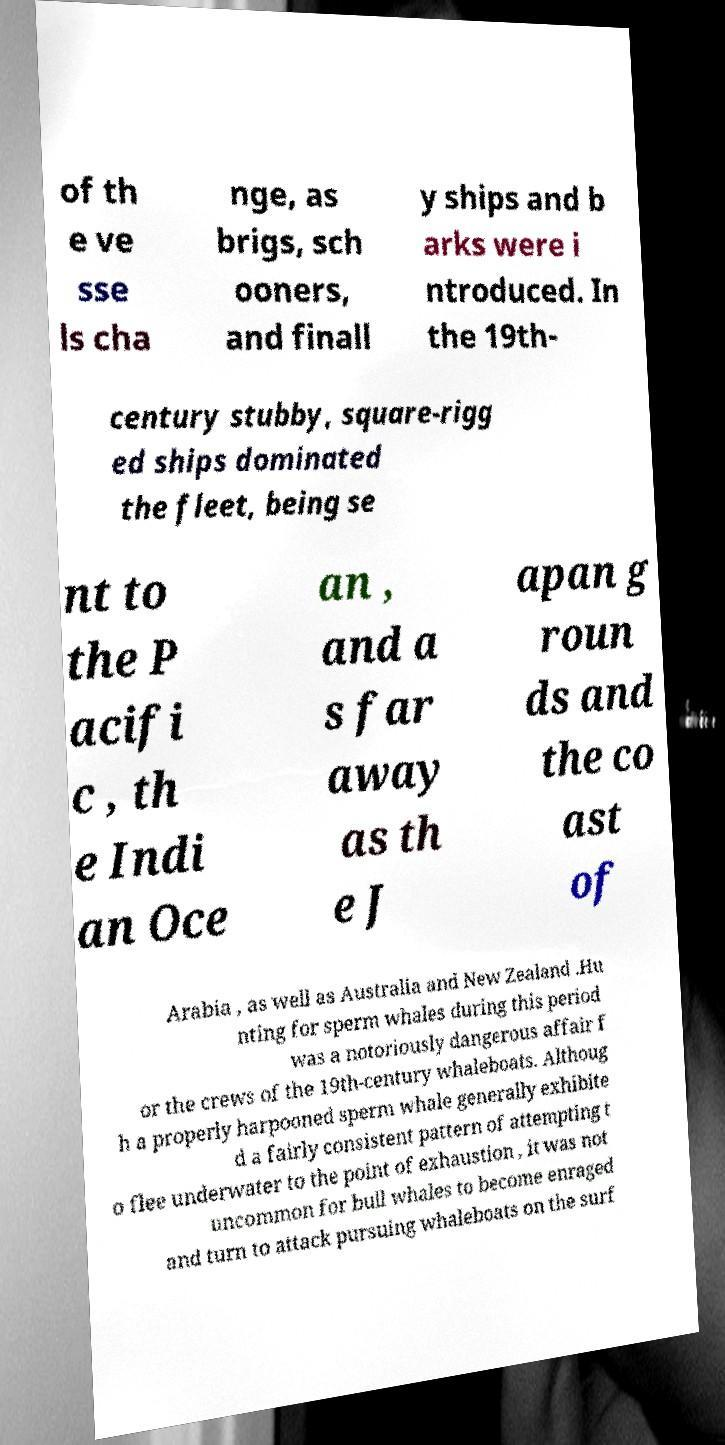For documentation purposes, I need the text within this image transcribed. Could you provide that? of th e ve sse ls cha nge, as brigs, sch ooners, and finall y ships and b arks were i ntroduced. In the 19th- century stubby, square-rigg ed ships dominated the fleet, being se nt to the P acifi c , th e Indi an Oce an , and a s far away as th e J apan g roun ds and the co ast of Arabia , as well as Australia and New Zealand .Hu nting for sperm whales during this period was a notoriously dangerous affair f or the crews of the 19th-century whaleboats. Althoug h a properly harpooned sperm whale generally exhibite d a fairly consistent pattern of attempting t o flee underwater to the point of exhaustion , it was not uncommon for bull whales to become enraged and turn to attack pursuing whaleboats on the surf 